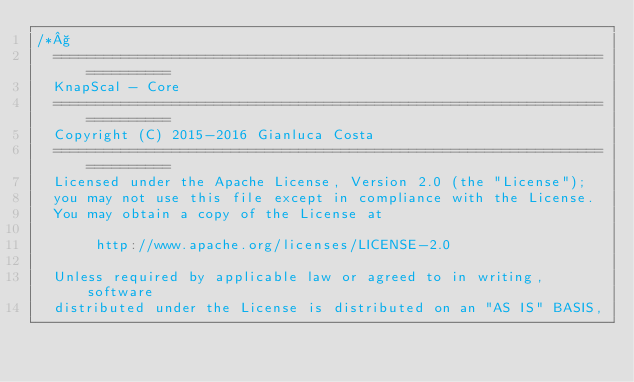Convert code to text. <code><loc_0><loc_0><loc_500><loc_500><_Scala_>/*§
  ===========================================================================
  KnapScal - Core
  ===========================================================================
  Copyright (C) 2015-2016 Gianluca Costa
  ===========================================================================
  Licensed under the Apache License, Version 2.0 (the "License");
  you may not use this file except in compliance with the License.
  You may obtain a copy of the License at

       http://www.apache.org/licenses/LICENSE-2.0

  Unless required by applicable law or agreed to in writing, software
  distributed under the License is distributed on an "AS IS" BASIS,</code> 